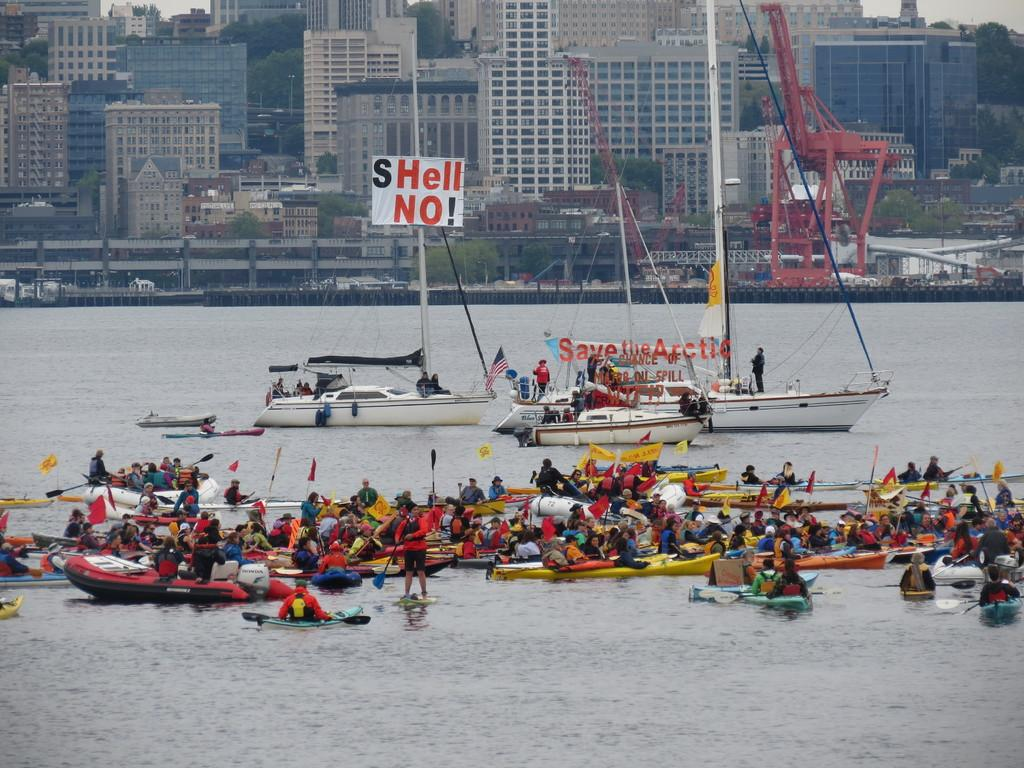What is in the water in the image? There are boats in the water in the image. What are the people on the boats doing? The people are sitting on the boats. What can be seen in the background of the image? There are buildings, trees, and vehicles visible in the background. How many sets of trees are present in the background? There are two sets of trees present in the background. What historical event is being reenacted on the stage in the image? There is no stage or historical event present in the image; it features boats in the water and people sitting on them. 